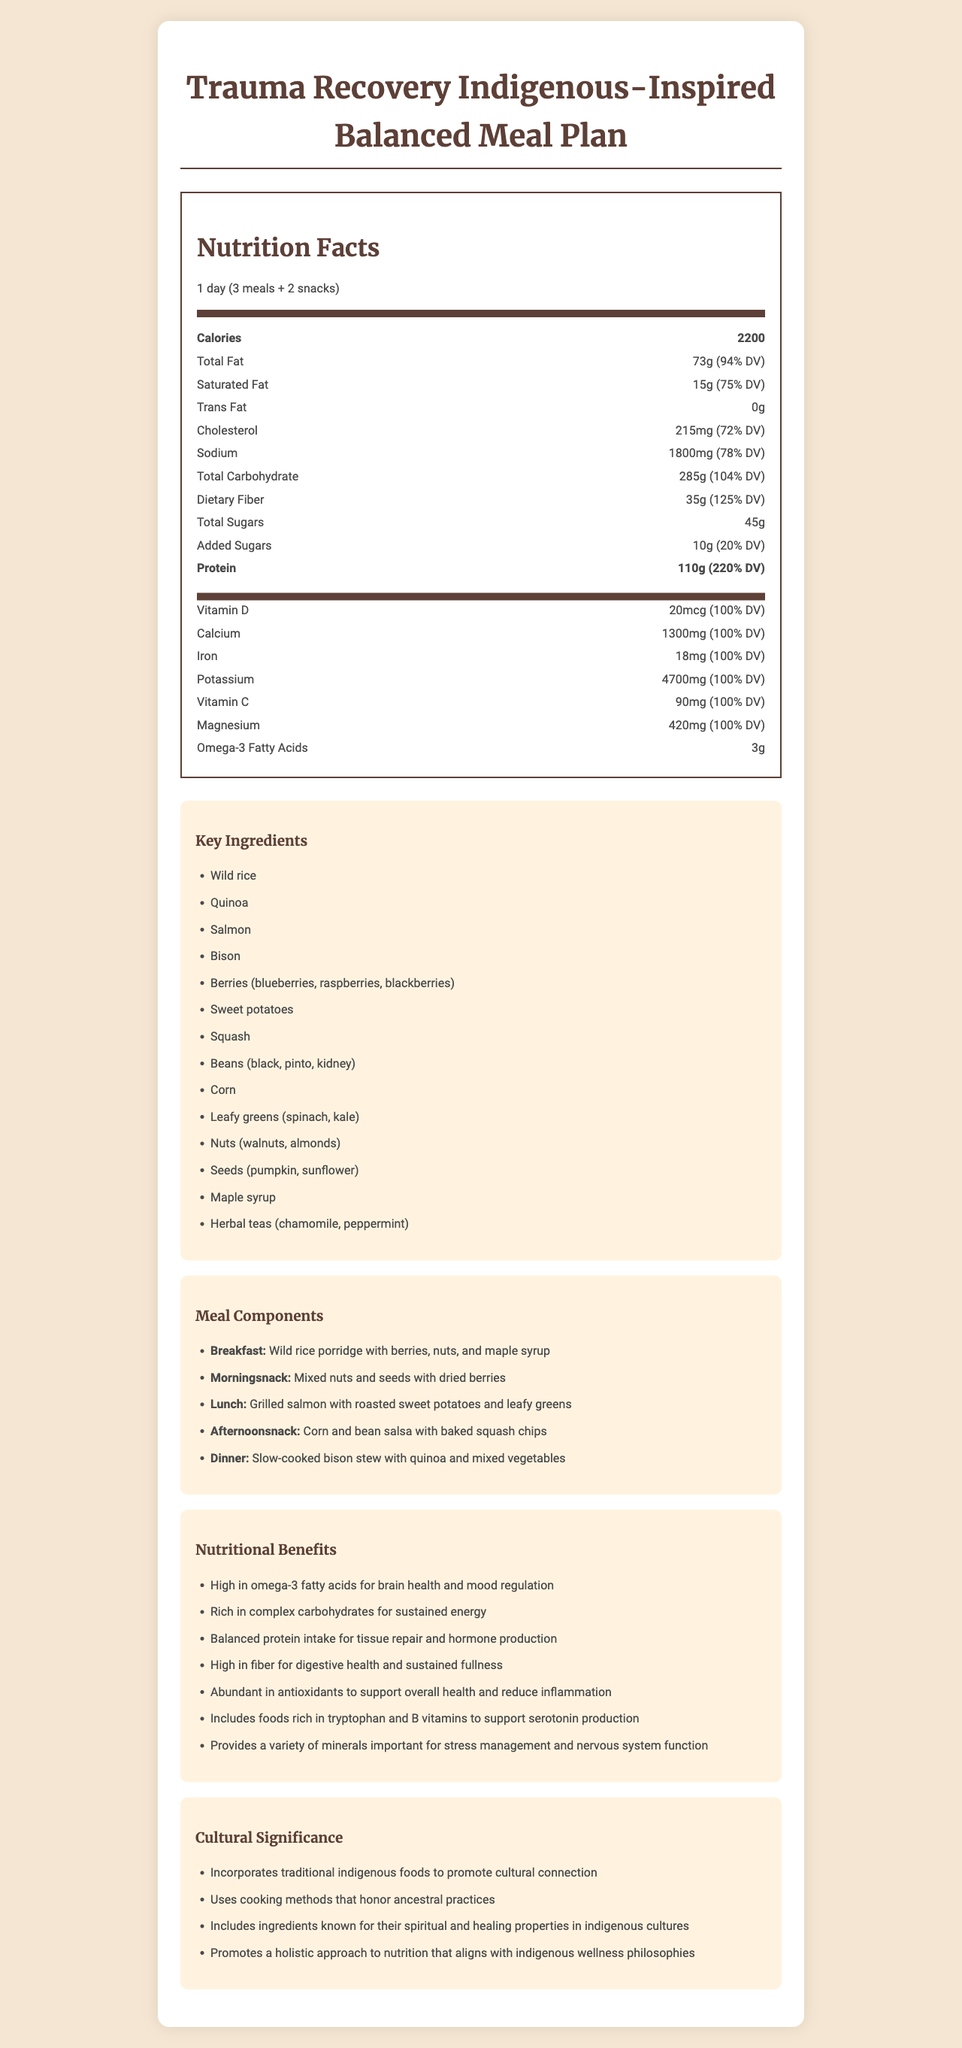what is the daily value percentage for dietary fiber in the meal plan? The daily value percentage for dietary fiber is shown as 125% in the nutrition facts section under macronutrients.
Answer: 125% how many calories are in one serving of the meal plan? One serving of the meal plan has 2200 calories as stated in the nutrition facts section.
Answer: 2200 what are the key ingredients in the meal plan? The document lists these as key ingredients under the "Key Ingredients" section.
Answer: Wild rice, Quinoa, Salmon, Bison, Berries, Sweet potatoes, Squash, Beans, Corn, Leafy greens, Nuts, Seeds, Maple syrup, and Herbal teas which meal does "Grilled salmon with roasted sweet potatoes and leafy greens" correspond to? The "Grilled salmon with roasted sweet potatoes and leafy greens" is listed under the lunch meal component.
Answer: Lunch how much omega-3 fatty acids are included in the meal plan? The amount of omega-3 fatty acids is specified as 3 grams in the nutrition facts section under micronutrients.
Answer: 3g which meal component includes "Corn and bean salsa with baked squash chips"? A. Breakfast B. Morning snack C. Afternoon snack D. Dinner The meal component for "Corn and bean salsa with baked squash chips" is listed under afternoon snack.
Answer: C. Afternoon snack what is the daily value percentage of protein in the meal plan? A. 75% B. 125% C. 220% D. 94% The document indicates that the daily value percentage for protein is 220% in the nutrition facts section.
Answer: C. 220% is there any added sugar in the meal plan? The document specifies 10g of added sugars in the nutrition facts section.
Answer: Yes describe the main idea of the document The document provides a comprehensive overview of a meal plan aimed at trauma recovery, emphasizing the importance of indigenous foods for cultural connection and healing. It covers various aspects such as macronutrients, micronutrients, meal components, and the cultural significance of the ingredients and cooking methods used.
Answer: The document outlines a balanced meal plan designed for individuals recovering from trauma, with a focus on incorporating indigenous foods. It details nutritional information, key ingredients, individual meal components, nutritional benefits, and cultural significance. how much magnesium is included in the meal plan? The meal plan includes 420 mg of magnesium as stated in the nutrition facts section under micronutrients.
Answer: 420mg does the document provide the recipe for each meal component? The document outlines the meal components but does not provide detailed recipes for each meal.
Answer: Not enough information what benefit does high omega-3 intake provide according to the document? The document lists high intake of omega-3 fatty acids as beneficial for brain health and mood regulation in the nutritional benefits section.
Answer: Brain health and mood regulation 